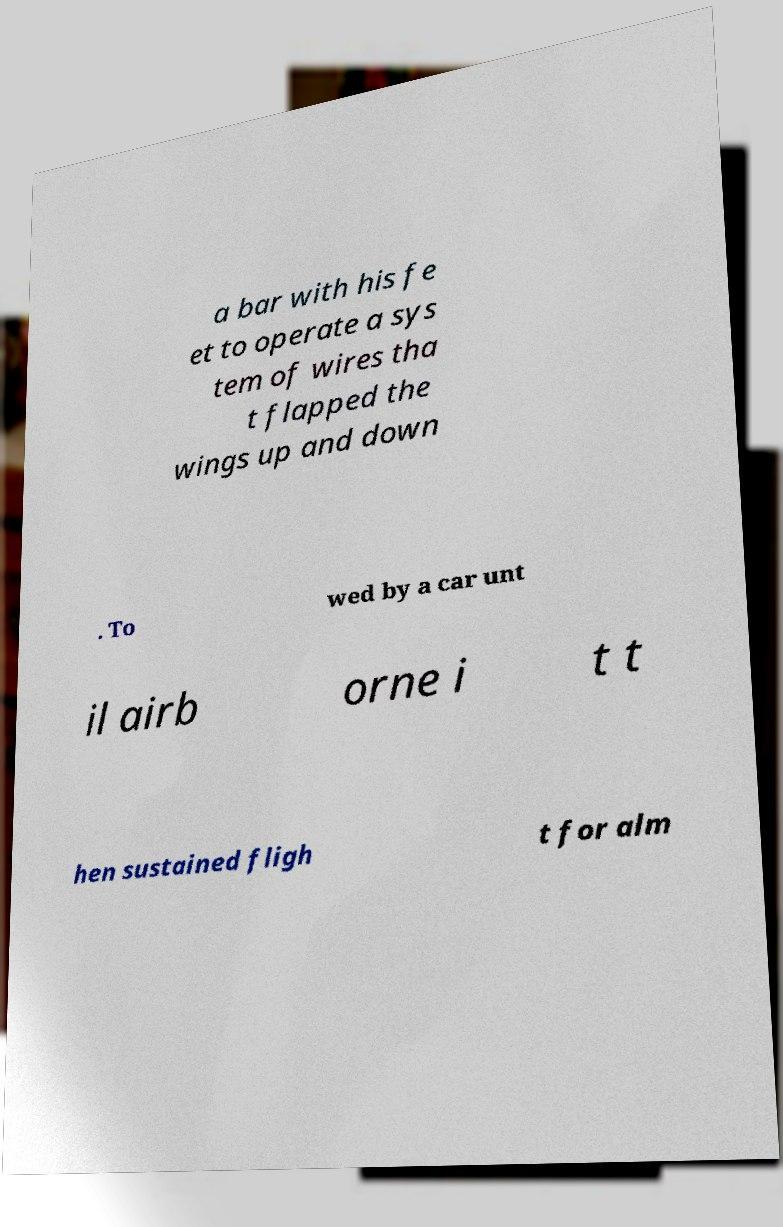Can you accurately transcribe the text from the provided image for me? a bar with his fe et to operate a sys tem of wires tha t flapped the wings up and down . To wed by a car unt il airb orne i t t hen sustained fligh t for alm 